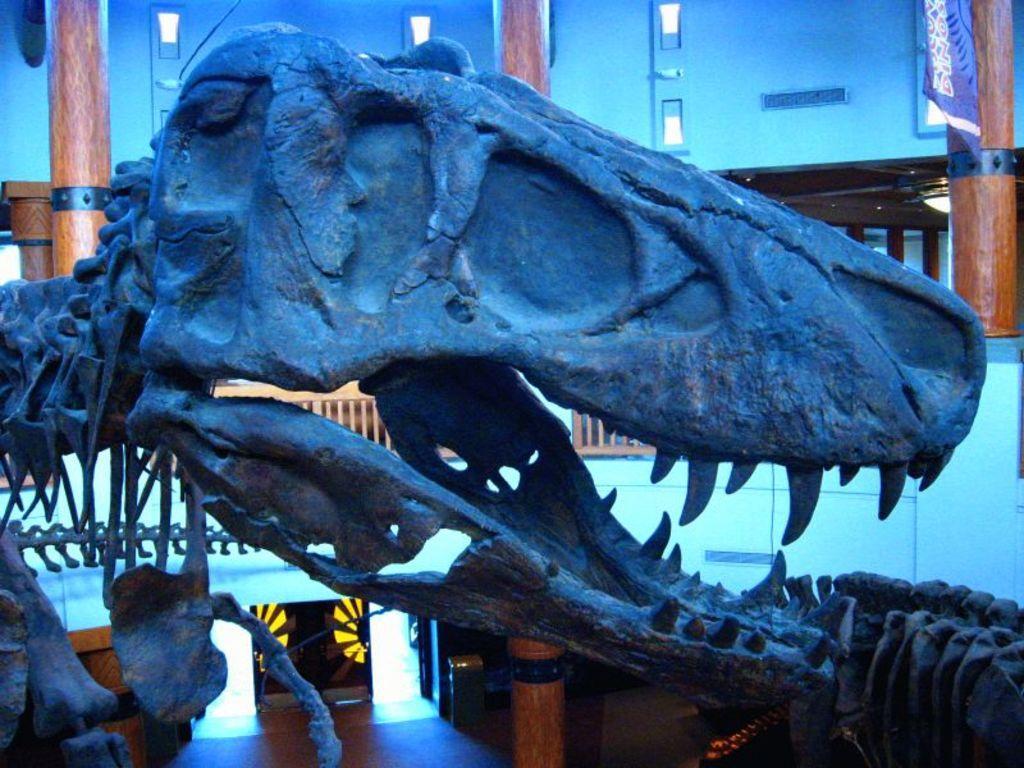Can you describe this image briefly? In this picture we can see a skull of a dinosaur, in the background there is a wall, it is an inside view of a building, we can see a cloth at the right top of the picture. 